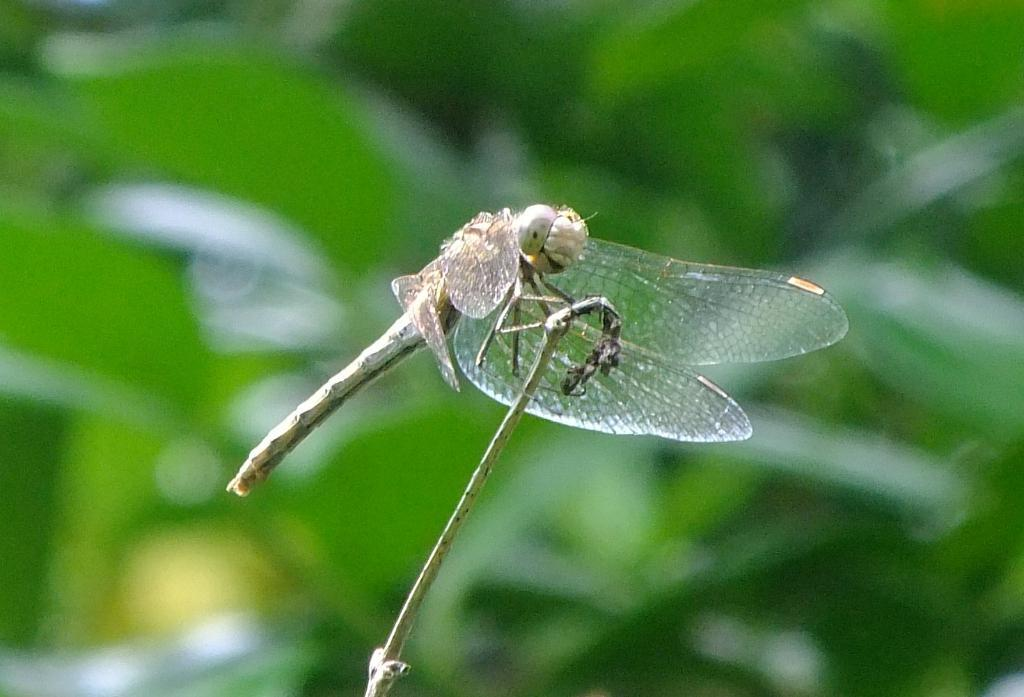What is the main subject of the image? There is a dragonfly in the image. What can be seen in the background of the image? There are leaves in the background of the image. How would you describe the appearance of the background? The background appears blurry. What type of spark can be seen coming from the dragonfly's wings in the image? There is no spark visible on the dragonfly's wings in the image. 